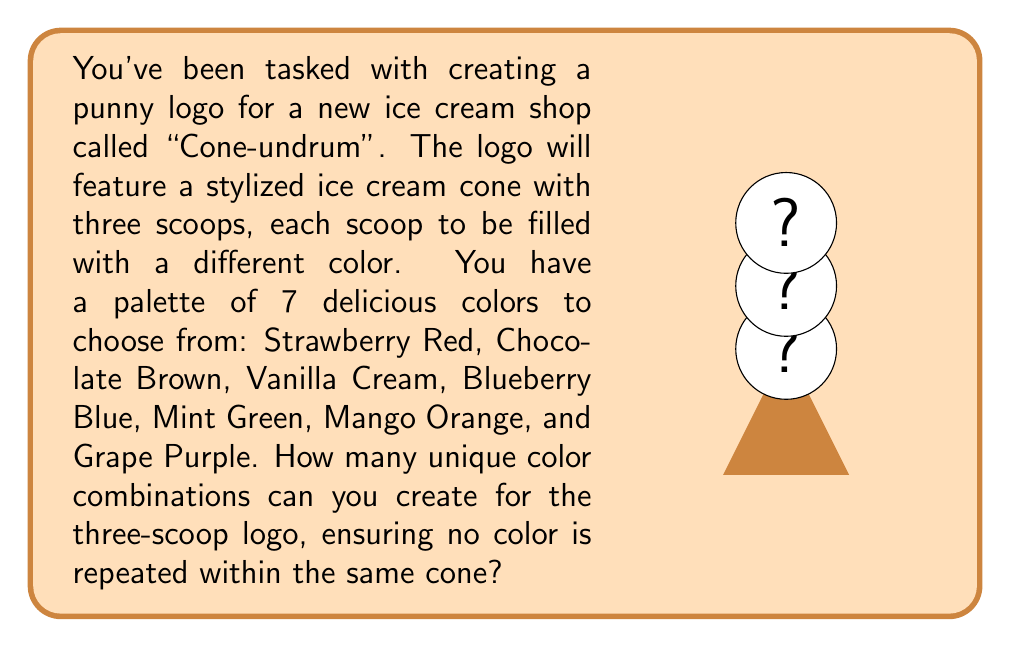Help me with this question. Let's break this down step-by-step:

1) First, we need to recognize that this is a permutation problem. We are selecting 3 colors out of 7, where the order matters (as the scoops are stacked), and no repetition is allowed.

2) This type of problem can be solved using the permutation formula:
   $$P(n,r) = \frac{n!}{(n-r)!}$$
   where $n$ is the total number of items to choose from, and $r$ is the number of items being chosen.

3) In this case:
   $n = 7$ (total colors available)
   $r = 3$ (scoops in the cone)

4) Plugging these values into our formula:
   $$P(7,3) = \frac{7!}{(7-3)!} = \frac{7!}{4!}$$

5) Let's calculate this:
   $$\frac{7!}{4!} = \frac{7 \times 6 \times 5 \times 4!}{4!}$$

6) The $4!$ cancels out in the numerator and denominator:
   $$7 \times 6 \times 5 = 210$$

Therefore, you can create 210 unique color combinations for your "Cone-undrum" logo. That's a lot of delicious possibilities to scoop up!
Answer: 210 unique combinations 